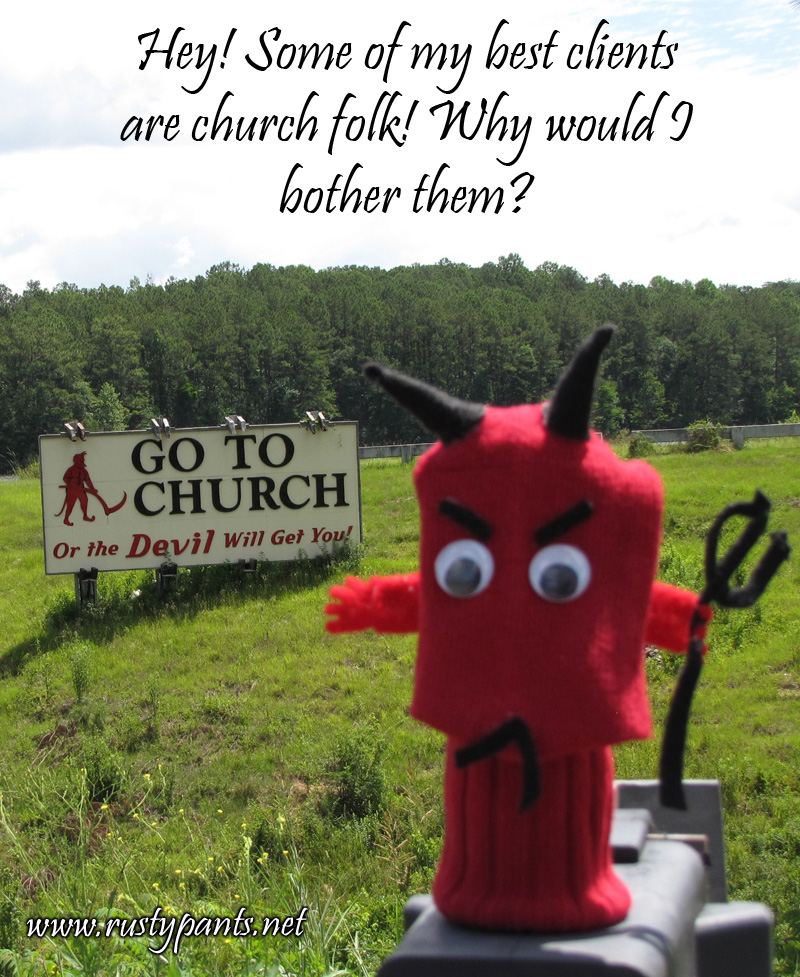What message is the sign trying to convey in this picture? The sign in the picture reads 'GO TO CHURCH Or the Devil Will Get You!' which humorously suggests that attending church is a safeguard against evil, represented by the devil figure on the sign. The sign aims to provoke thought about religious attendance with a blend of seriousness and humor, perhaps as a playful way to encourage churchgoing. 